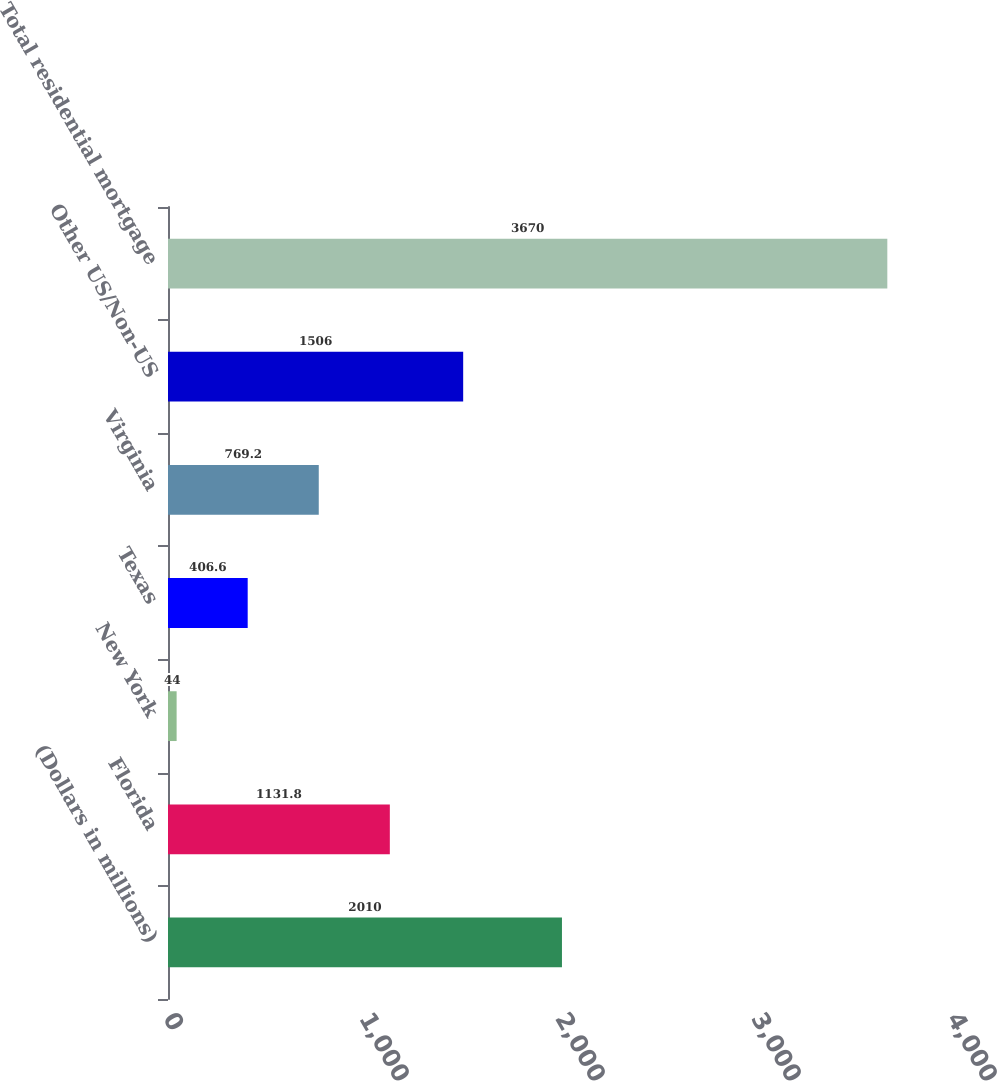<chart> <loc_0><loc_0><loc_500><loc_500><bar_chart><fcel>(Dollars in millions)<fcel>Florida<fcel>New York<fcel>Texas<fcel>Virginia<fcel>Other US/Non-US<fcel>Total residential mortgage<nl><fcel>2010<fcel>1131.8<fcel>44<fcel>406.6<fcel>769.2<fcel>1506<fcel>3670<nl></chart> 